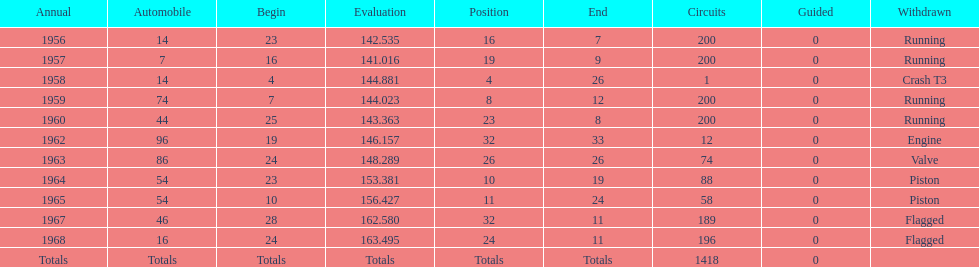Did bob veith drive more indy 500 laps in the 1950s or 1960s? 1960s. 